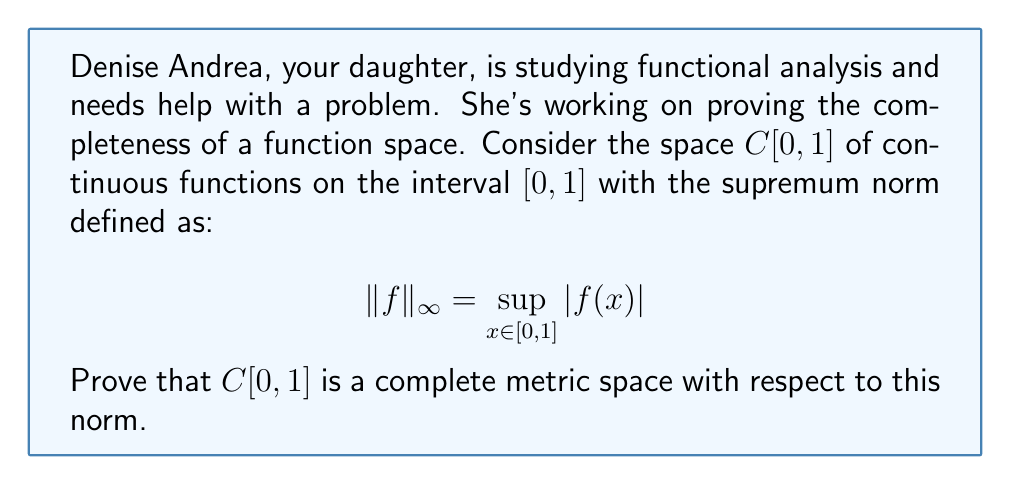Can you answer this question? To prove that $C[0,1]$ is complete, we need to show that every Cauchy sequence in $C[0,1]$ converges to a function in $C[0,1]$. Let's break this down step-by-step:

1) Let $(f_n)$ be a Cauchy sequence in $C[0,1]$. This means that for any $\epsilon > 0$, there exists an $N \in \mathbb{N}$ such that for all $m, n \geq N$, we have:

   $$\|f_m - f_n\|_{\infty} < \epsilon$$

2) For any fixed $x \in [0,1]$, $(f_n(x))$ is a Cauchy sequence in $\mathbb{R}$. This is because:

   $|f_m(x) - f_n(x)| \leq \sup_{y \in [0,1]} |f_m(y) - f_n(y)| = \|f_m - f_n\|_{\infty} < \epsilon$

3) Since $\mathbb{R}$ is complete, $(f_n(x))$ converges for each $x \in [0,1]$. Let's define:

   $$f(x) = \lim_{n \to \infty} f_n(x)$$

4) We need to show that $f \in C[0,1]$ and that $f_n \to f$ in the supremum norm.

5) To prove continuity of $f$, let $x, y \in [0,1]$. Then:

   $|f(x) - f(y)| \leq |f(x) - f_n(x)| + |f_n(x) - f_n(y)| + |f_n(y) - f(y)|$

   The first and third terms can be made arbitrarily small by choosing large $n$, and the middle term is small for $x$ close to $y$ due to the uniform continuity of $f_n$ on $[0,1]$.

6) To show $f_n \to f$ in the supremum norm, we need to prove that for any $\epsilon > 0$, there exists $N$ such that for all $n \geq N$:

   $$\|f_n - f\|_{\infty} < \epsilon$$

   This can be done using the Cauchy property of $(f_n)$ and the pointwise convergence to $f$.

Therefore, $C[0,1]$ is complete with respect to the supremum norm.
Answer: $C[0,1]$ is a complete metric space with respect to the supremum norm. 